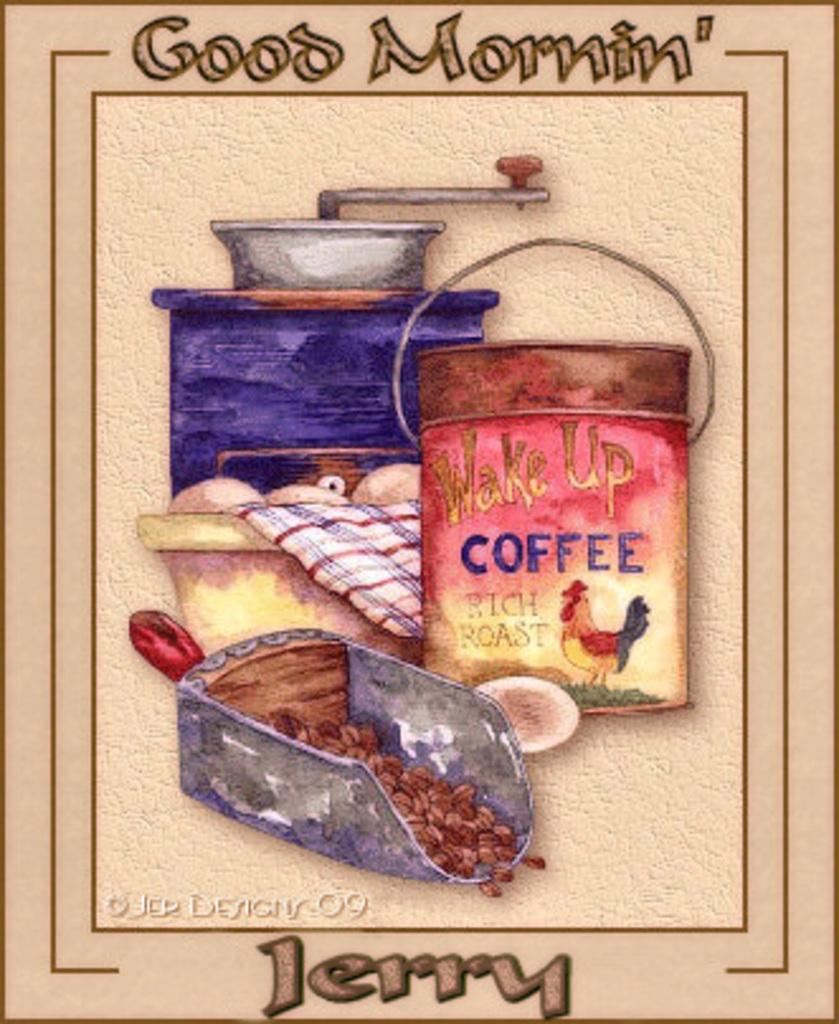What can be observed about the nature of the image? The image is edited. What can be seen in the middle of the image? There are objects in the center of the image. Where is text located in the image? There is text at the top and bottom of the image. Can you see any animals from the zoo in the image? There is no mention of animals or a zoo in the provided facts, so it cannot be determined if any are present in the image. 